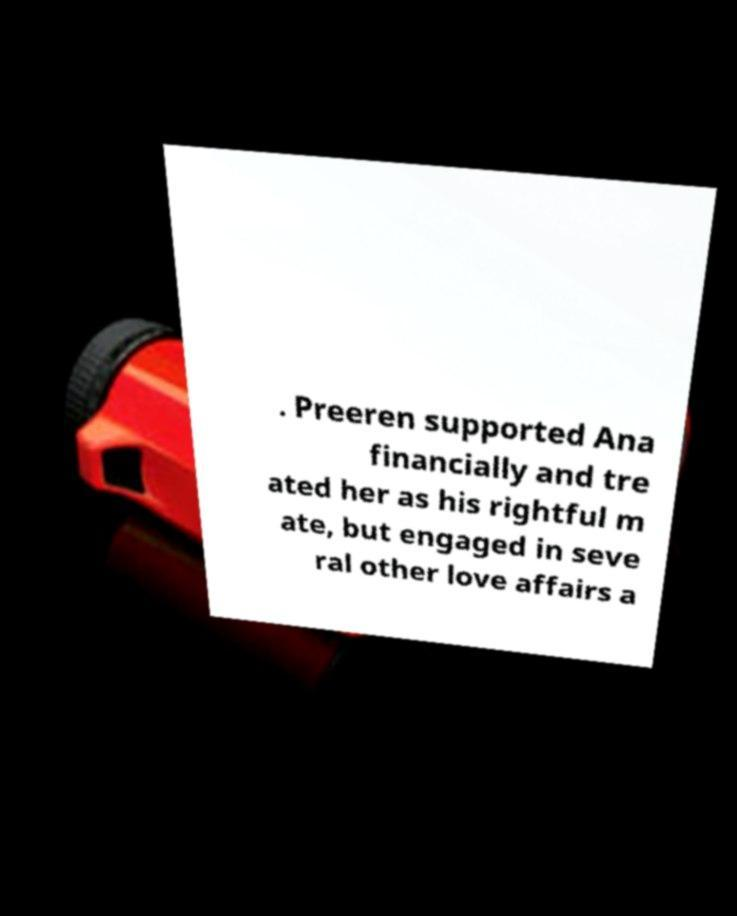What messages or text are displayed in this image? I need them in a readable, typed format. . Preeren supported Ana financially and tre ated her as his rightful m ate, but engaged in seve ral other love affairs a 